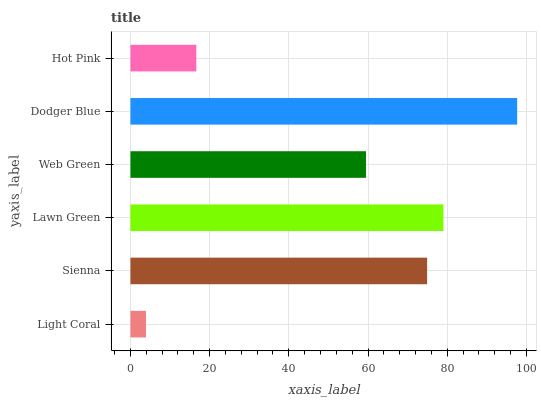Is Light Coral the minimum?
Answer yes or no. Yes. Is Dodger Blue the maximum?
Answer yes or no. Yes. Is Sienna the minimum?
Answer yes or no. No. Is Sienna the maximum?
Answer yes or no. No. Is Sienna greater than Light Coral?
Answer yes or no. Yes. Is Light Coral less than Sienna?
Answer yes or no. Yes. Is Light Coral greater than Sienna?
Answer yes or no. No. Is Sienna less than Light Coral?
Answer yes or no. No. Is Sienna the high median?
Answer yes or no. Yes. Is Web Green the low median?
Answer yes or no. Yes. Is Light Coral the high median?
Answer yes or no. No. Is Dodger Blue the low median?
Answer yes or no. No. 